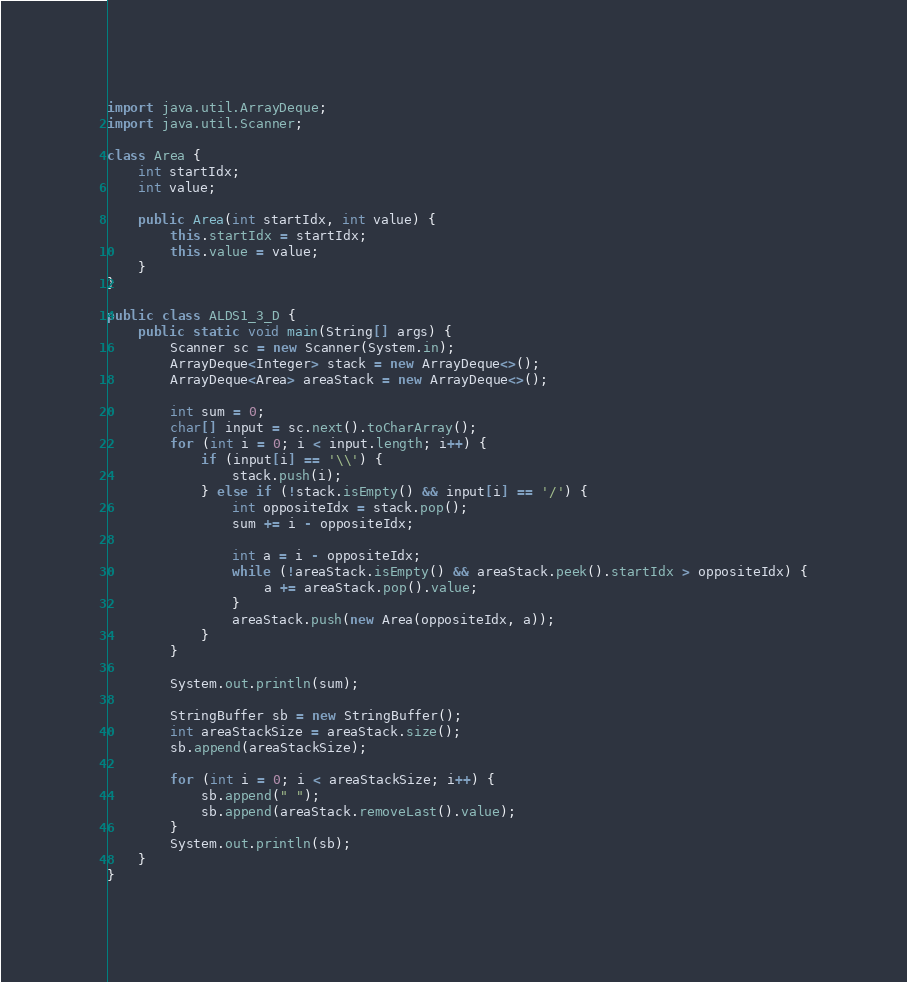Convert code to text. <code><loc_0><loc_0><loc_500><loc_500><_Java_>import java.util.ArrayDeque;
import java.util.Scanner;

class Area {
    int startIdx;
    int value;

    public Area(int startIdx, int value) {
        this.startIdx = startIdx;
        this.value = value;
    }
}

public class ALDS1_3_D {
    public static void main(String[] args) {
        Scanner sc = new Scanner(System.in);
        ArrayDeque<Integer> stack = new ArrayDeque<>();
        ArrayDeque<Area> areaStack = new ArrayDeque<>();

        int sum = 0;
        char[] input = sc.next().toCharArray();
        for (int i = 0; i < input.length; i++) {
            if (input[i] == '\\') {
                stack.push(i);
            } else if (!stack.isEmpty() && input[i] == '/') {
                int oppositeIdx = stack.pop();
                sum += i - oppositeIdx;

                int a = i - oppositeIdx;
                while (!areaStack.isEmpty() && areaStack.peek().startIdx > oppositeIdx) {
                    a += areaStack.pop().value;
                }
                areaStack.push(new Area(oppositeIdx, a));
            }
        }

        System.out.println(sum);

        StringBuffer sb = new StringBuffer();
        int areaStackSize = areaStack.size();
        sb.append(areaStackSize);

        for (int i = 0; i < areaStackSize; i++) {
            sb.append(" ");
            sb.append(areaStack.removeLast().value);
        }
        System.out.println(sb);
    }
}

</code> 